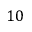<formula> <loc_0><loc_0><loc_500><loc_500>1 0</formula> 